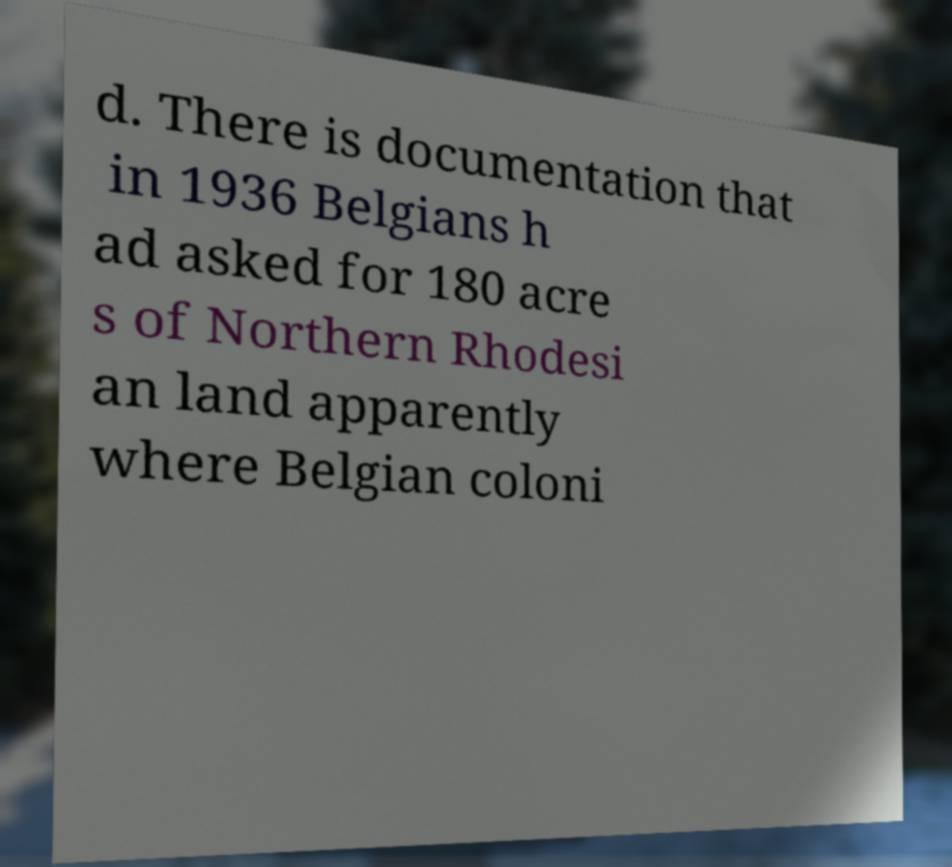I need the written content from this picture converted into text. Can you do that? d. There is documentation that in 1936 Belgians h ad asked for 180 acre s of Northern Rhodesi an land apparently where Belgian coloni 